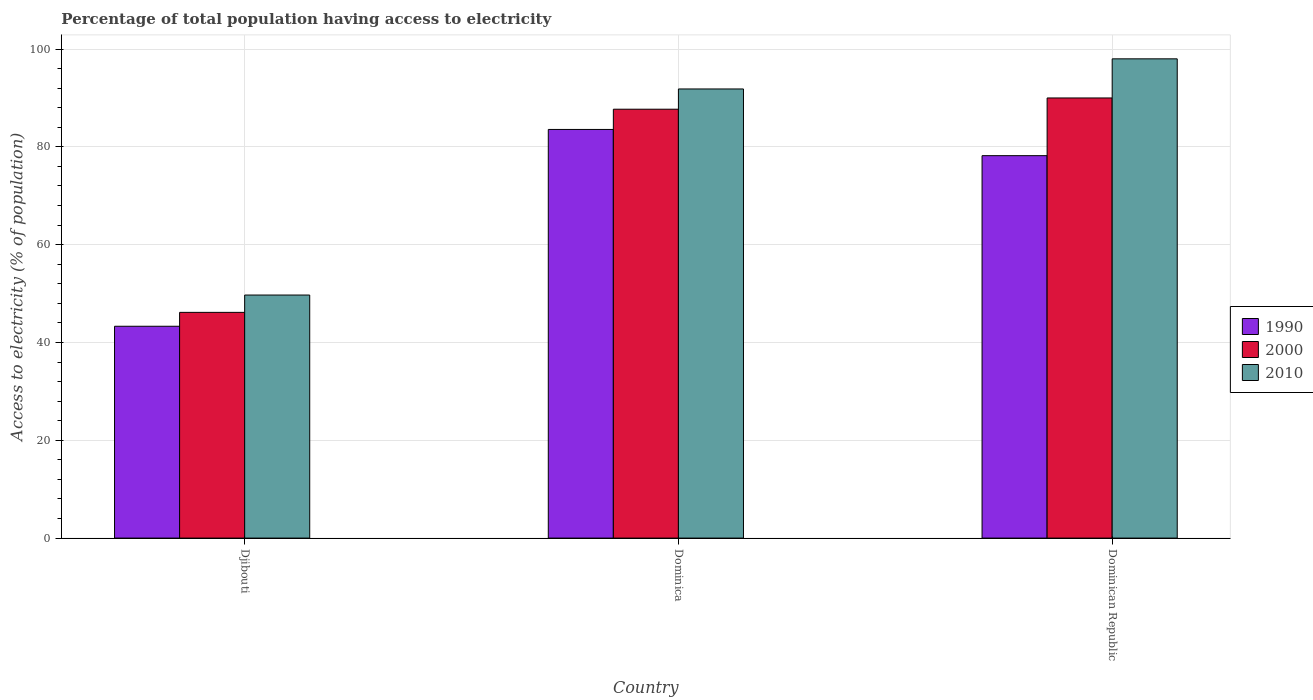How many groups of bars are there?
Your answer should be very brief. 3. What is the label of the 1st group of bars from the left?
Your response must be concise. Djibouti. In how many cases, is the number of bars for a given country not equal to the number of legend labels?
Your answer should be very brief. 0. What is the percentage of population that have access to electricity in 2010 in Djibouti?
Offer a terse response. 49.7. Across all countries, what is the maximum percentage of population that have access to electricity in 1990?
Offer a terse response. 83.56. Across all countries, what is the minimum percentage of population that have access to electricity in 2000?
Ensure brevity in your answer.  46.16. In which country was the percentage of population that have access to electricity in 2010 maximum?
Give a very brief answer. Dominican Republic. In which country was the percentage of population that have access to electricity in 2010 minimum?
Offer a very short reply. Djibouti. What is the total percentage of population that have access to electricity in 2010 in the graph?
Make the answer very short. 239.54. What is the difference between the percentage of population that have access to electricity in 2000 in Djibouti and that in Dominican Republic?
Make the answer very short. -43.84. What is the difference between the percentage of population that have access to electricity in 2000 in Dominican Republic and the percentage of population that have access to electricity in 2010 in Dominica?
Offer a terse response. -1.84. What is the average percentage of population that have access to electricity in 2000 per country?
Provide a succinct answer. 74.62. What is the difference between the percentage of population that have access to electricity of/in 2010 and percentage of population that have access to electricity of/in 1990 in Dominican Republic?
Offer a very short reply. 19.8. In how many countries, is the percentage of population that have access to electricity in 1990 greater than 8 %?
Give a very brief answer. 3. What is the ratio of the percentage of population that have access to electricity in 2010 in Dominica to that in Dominican Republic?
Offer a very short reply. 0.94. Is the percentage of population that have access to electricity in 2010 in Djibouti less than that in Dominica?
Provide a short and direct response. Yes. What is the difference between the highest and the second highest percentage of population that have access to electricity in 1990?
Your answer should be very brief. -40.25. What is the difference between the highest and the lowest percentage of population that have access to electricity in 1990?
Your answer should be compact. 40.25. In how many countries, is the percentage of population that have access to electricity in 2000 greater than the average percentage of population that have access to electricity in 2000 taken over all countries?
Your response must be concise. 2. Is the sum of the percentage of population that have access to electricity in 2010 in Dominica and Dominican Republic greater than the maximum percentage of population that have access to electricity in 2000 across all countries?
Ensure brevity in your answer.  Yes. What does the 2nd bar from the left in Dominican Republic represents?
Provide a short and direct response. 2000. Is it the case that in every country, the sum of the percentage of population that have access to electricity in 2000 and percentage of population that have access to electricity in 2010 is greater than the percentage of population that have access to electricity in 1990?
Make the answer very short. Yes. How many bars are there?
Your answer should be compact. 9. How many countries are there in the graph?
Offer a very short reply. 3. Are the values on the major ticks of Y-axis written in scientific E-notation?
Provide a succinct answer. No. Does the graph contain any zero values?
Ensure brevity in your answer.  No. Where does the legend appear in the graph?
Your answer should be very brief. Center right. What is the title of the graph?
Provide a succinct answer. Percentage of total population having access to electricity. Does "1998" appear as one of the legend labels in the graph?
Provide a short and direct response. No. What is the label or title of the Y-axis?
Provide a succinct answer. Access to electricity (% of population). What is the Access to electricity (% of population) in 1990 in Djibouti?
Keep it short and to the point. 43.32. What is the Access to electricity (% of population) in 2000 in Djibouti?
Give a very brief answer. 46.16. What is the Access to electricity (% of population) of 2010 in Djibouti?
Ensure brevity in your answer.  49.7. What is the Access to electricity (% of population) of 1990 in Dominica?
Your response must be concise. 83.56. What is the Access to electricity (% of population) in 2000 in Dominica?
Ensure brevity in your answer.  87.7. What is the Access to electricity (% of population) in 2010 in Dominica?
Provide a short and direct response. 91.84. What is the Access to electricity (% of population) of 1990 in Dominican Republic?
Your answer should be compact. 78.2. What is the Access to electricity (% of population) of 2000 in Dominican Republic?
Give a very brief answer. 90. What is the Access to electricity (% of population) in 2010 in Dominican Republic?
Provide a short and direct response. 98. Across all countries, what is the maximum Access to electricity (% of population) of 1990?
Keep it short and to the point. 83.56. Across all countries, what is the maximum Access to electricity (% of population) in 2000?
Make the answer very short. 90. Across all countries, what is the maximum Access to electricity (% of population) of 2010?
Provide a succinct answer. 98. Across all countries, what is the minimum Access to electricity (% of population) in 1990?
Your answer should be compact. 43.32. Across all countries, what is the minimum Access to electricity (% of population) of 2000?
Keep it short and to the point. 46.16. Across all countries, what is the minimum Access to electricity (% of population) in 2010?
Provide a short and direct response. 49.7. What is the total Access to electricity (% of population) of 1990 in the graph?
Provide a succinct answer. 205.08. What is the total Access to electricity (% of population) in 2000 in the graph?
Offer a very short reply. 223.86. What is the total Access to electricity (% of population) of 2010 in the graph?
Offer a terse response. 239.54. What is the difference between the Access to electricity (% of population) in 1990 in Djibouti and that in Dominica?
Your answer should be very brief. -40.25. What is the difference between the Access to electricity (% of population) of 2000 in Djibouti and that in Dominica?
Your response must be concise. -41.54. What is the difference between the Access to electricity (% of population) in 2010 in Djibouti and that in Dominica?
Your answer should be compact. -42.14. What is the difference between the Access to electricity (% of population) in 1990 in Djibouti and that in Dominican Republic?
Give a very brief answer. -34.88. What is the difference between the Access to electricity (% of population) in 2000 in Djibouti and that in Dominican Republic?
Provide a short and direct response. -43.84. What is the difference between the Access to electricity (% of population) in 2010 in Djibouti and that in Dominican Republic?
Make the answer very short. -48.3. What is the difference between the Access to electricity (% of population) of 1990 in Dominica and that in Dominican Republic?
Offer a very short reply. 5.36. What is the difference between the Access to electricity (% of population) in 2000 in Dominica and that in Dominican Republic?
Your response must be concise. -2.3. What is the difference between the Access to electricity (% of population) of 2010 in Dominica and that in Dominican Republic?
Offer a terse response. -6.16. What is the difference between the Access to electricity (% of population) in 1990 in Djibouti and the Access to electricity (% of population) in 2000 in Dominica?
Give a very brief answer. -44.38. What is the difference between the Access to electricity (% of population) of 1990 in Djibouti and the Access to electricity (% of population) of 2010 in Dominica?
Ensure brevity in your answer.  -48.52. What is the difference between the Access to electricity (% of population) of 2000 in Djibouti and the Access to electricity (% of population) of 2010 in Dominica?
Offer a terse response. -45.68. What is the difference between the Access to electricity (% of population) of 1990 in Djibouti and the Access to electricity (% of population) of 2000 in Dominican Republic?
Offer a terse response. -46.68. What is the difference between the Access to electricity (% of population) of 1990 in Djibouti and the Access to electricity (% of population) of 2010 in Dominican Republic?
Your answer should be compact. -54.68. What is the difference between the Access to electricity (% of population) in 2000 in Djibouti and the Access to electricity (% of population) in 2010 in Dominican Republic?
Offer a very short reply. -51.84. What is the difference between the Access to electricity (% of population) of 1990 in Dominica and the Access to electricity (% of population) of 2000 in Dominican Republic?
Your answer should be compact. -6.44. What is the difference between the Access to electricity (% of population) in 1990 in Dominica and the Access to electricity (% of population) in 2010 in Dominican Republic?
Offer a terse response. -14.44. What is the difference between the Access to electricity (% of population) of 2000 in Dominica and the Access to electricity (% of population) of 2010 in Dominican Republic?
Offer a terse response. -10.3. What is the average Access to electricity (% of population) of 1990 per country?
Your answer should be compact. 68.36. What is the average Access to electricity (% of population) in 2000 per country?
Offer a terse response. 74.62. What is the average Access to electricity (% of population) of 2010 per country?
Provide a succinct answer. 79.85. What is the difference between the Access to electricity (% of population) in 1990 and Access to electricity (% of population) in 2000 in Djibouti?
Your response must be concise. -2.84. What is the difference between the Access to electricity (% of population) of 1990 and Access to electricity (% of population) of 2010 in Djibouti?
Offer a terse response. -6.38. What is the difference between the Access to electricity (% of population) of 2000 and Access to electricity (% of population) of 2010 in Djibouti?
Provide a short and direct response. -3.54. What is the difference between the Access to electricity (% of population) in 1990 and Access to electricity (% of population) in 2000 in Dominica?
Give a very brief answer. -4.14. What is the difference between the Access to electricity (% of population) in 1990 and Access to electricity (% of population) in 2010 in Dominica?
Your response must be concise. -8.28. What is the difference between the Access to electricity (% of population) in 2000 and Access to electricity (% of population) in 2010 in Dominica?
Keep it short and to the point. -4.14. What is the difference between the Access to electricity (% of population) in 1990 and Access to electricity (% of population) in 2010 in Dominican Republic?
Keep it short and to the point. -19.8. What is the ratio of the Access to electricity (% of population) in 1990 in Djibouti to that in Dominica?
Provide a succinct answer. 0.52. What is the ratio of the Access to electricity (% of population) of 2000 in Djibouti to that in Dominica?
Your response must be concise. 0.53. What is the ratio of the Access to electricity (% of population) in 2010 in Djibouti to that in Dominica?
Provide a succinct answer. 0.54. What is the ratio of the Access to electricity (% of population) of 1990 in Djibouti to that in Dominican Republic?
Offer a very short reply. 0.55. What is the ratio of the Access to electricity (% of population) in 2000 in Djibouti to that in Dominican Republic?
Keep it short and to the point. 0.51. What is the ratio of the Access to electricity (% of population) in 2010 in Djibouti to that in Dominican Republic?
Give a very brief answer. 0.51. What is the ratio of the Access to electricity (% of population) of 1990 in Dominica to that in Dominican Republic?
Keep it short and to the point. 1.07. What is the ratio of the Access to electricity (% of population) of 2000 in Dominica to that in Dominican Republic?
Provide a short and direct response. 0.97. What is the ratio of the Access to electricity (% of population) of 2010 in Dominica to that in Dominican Republic?
Provide a succinct answer. 0.94. What is the difference between the highest and the second highest Access to electricity (% of population) of 1990?
Your answer should be very brief. 5.36. What is the difference between the highest and the second highest Access to electricity (% of population) in 2000?
Give a very brief answer. 2.3. What is the difference between the highest and the second highest Access to electricity (% of population) of 2010?
Keep it short and to the point. 6.16. What is the difference between the highest and the lowest Access to electricity (% of population) in 1990?
Provide a succinct answer. 40.25. What is the difference between the highest and the lowest Access to electricity (% of population) in 2000?
Make the answer very short. 43.84. What is the difference between the highest and the lowest Access to electricity (% of population) in 2010?
Keep it short and to the point. 48.3. 